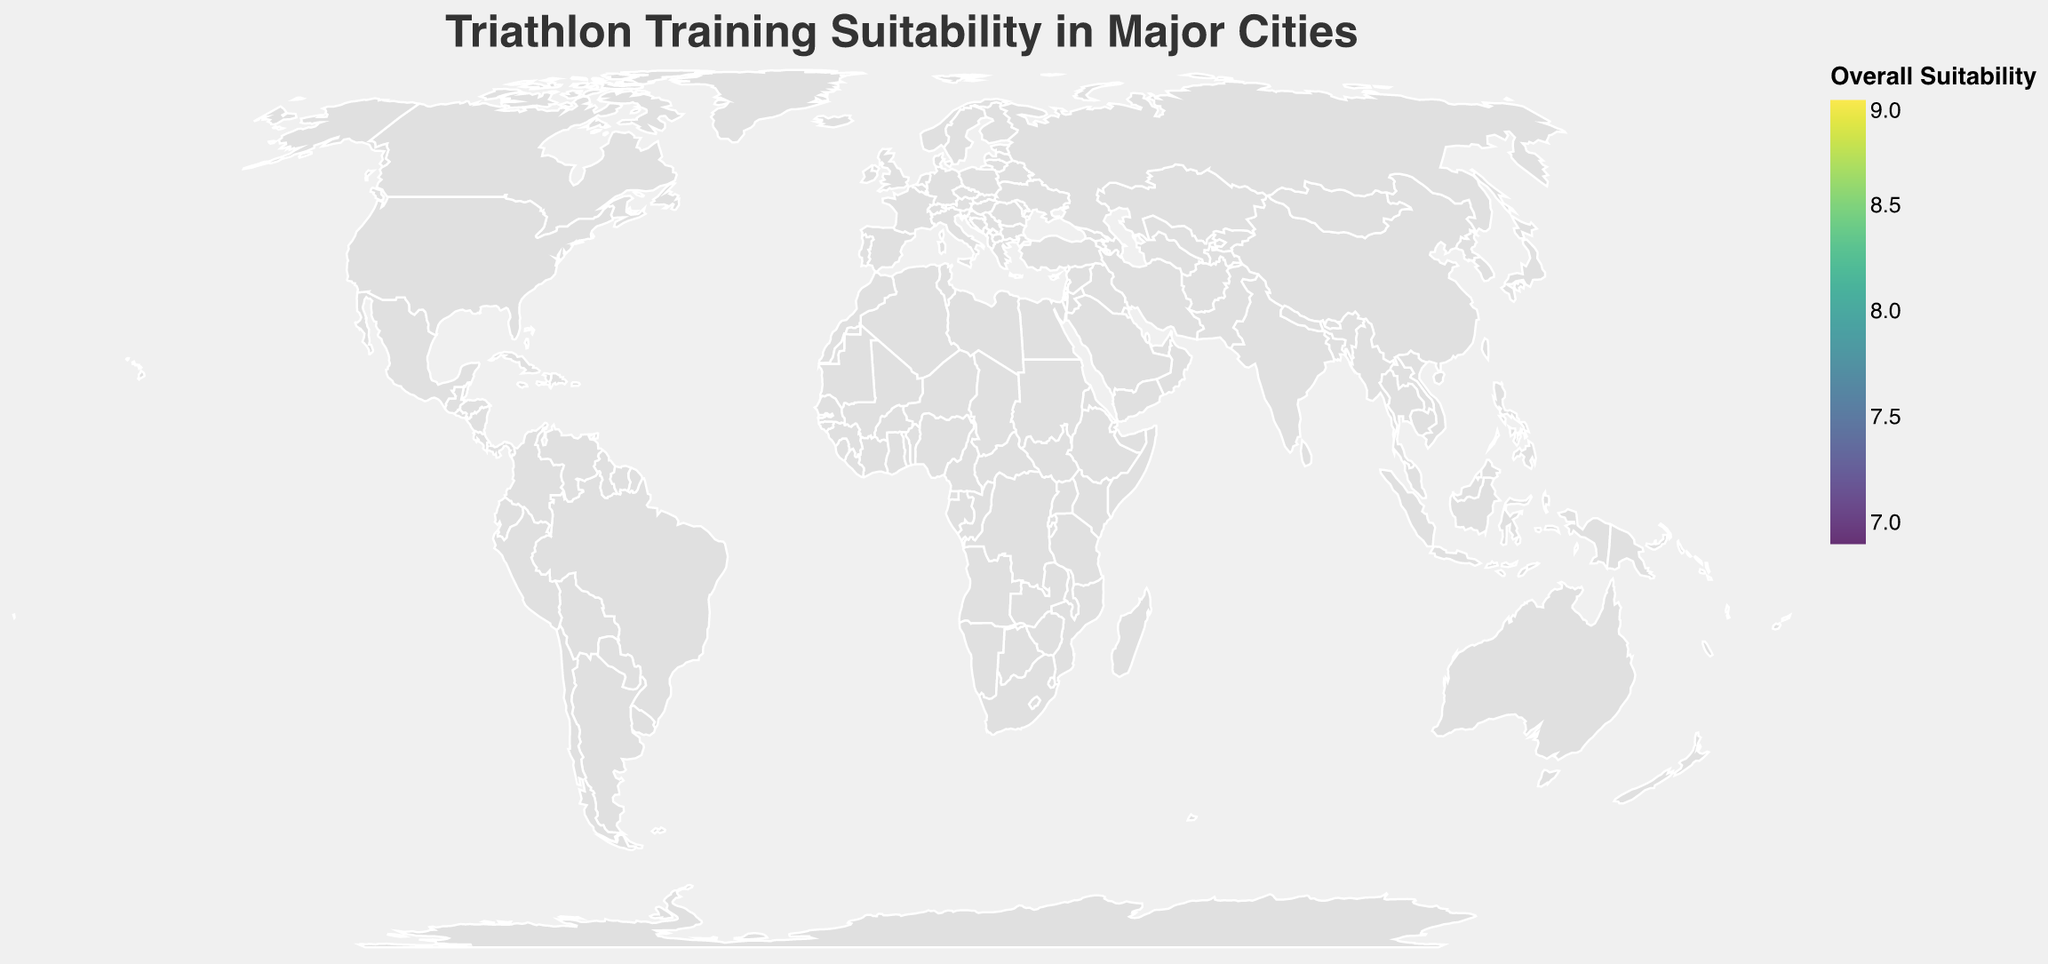What is the title of the figure? The title is typically displayed at the top of the figure and summarizes what the figure represents. Here, the title of the figure is "Triathlon Training Suitability in Major Cities".
Answer: Triathlon Training Suitability in Major Cities Which city has the highest running trail density? By looking at the tooltip for each data point, we see that Vancouver has the highest value for Running_Trail_Density, which is 9.1.
Answer: Vancouver Which city has the lowest overall suitability for triathlon training? Checking the tooltip data for each city, Tokyo stands out with the lowest Overall_Suitability value of 6.9.
Answer: Tokyo What are the overall suitability scores for San Francisco and Sydney? Hovering over San Francisco and Sydney reveals their Overall_Suitability values as 8.3 and 8.4, respectively.
Answer: 8.3 and 8.4 How do the cycling route densities of Amsterdam and Copenhagen compare? Amsterdam has a Cycling_Route_Density of 9.5 and Copenhagen has a value of 9.2. Comparing these, Amsterdam has a slightly higher cycling route density.
Answer: Amsterdam has a higher cycling route density Which cities have an overall suitability score greater than 8.5? The cities with an Overall_Suitability greater than 8.5 are Vancouver and Copenhagen, with scores of 9.0 and 8.7, respectively.
Answer: Vancouver, Copenhagen If you average the running trail densities of New York City, Sydney, and Amsterdam, what do you get? The running trail densities are 8.5 for New York City, 8.7 for Sydney, and 7.5 for Amsterdam. Averaging these: (8.5 + 8.7 + 7.5) / 3 = 8.2.
Answer: 8.2 Which city displays the largest contrast between running trail density and cycling route density? Vancouver has a running trail density of 9.1 and a cycling route density of 8.8, a contrast of 0.3, the smallest observed. The largest contrast is observed in Amsterdam, with running trail and cycling route densities of 7.5 and 9.5, respectively, giving a contrast of 2.
Answer: Amsterdam Which city would be most suitable for you if you value high-density running trails more than cycling routes? Vancouver has the highest running trail density (9.1) and also a high Overall_Suitability score of 9.0, making it ideal for those valuing running trails.
Answer: Vancouver 